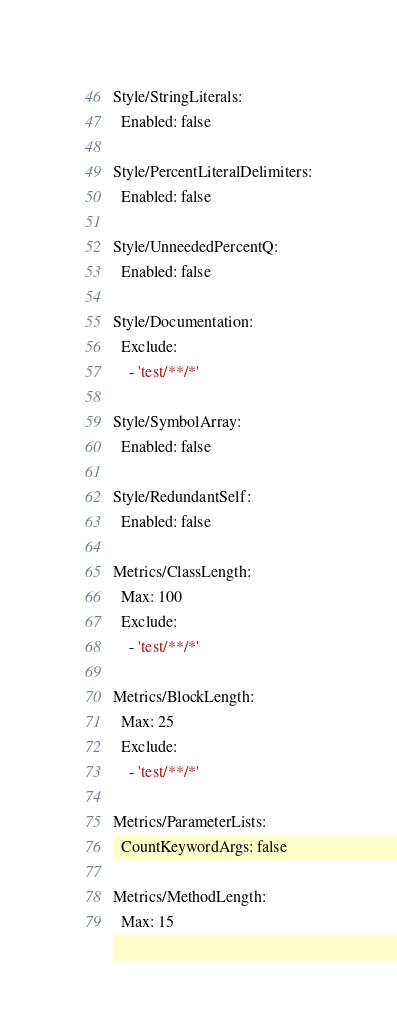<code> <loc_0><loc_0><loc_500><loc_500><_YAML_>Style/StringLiterals:
  Enabled: false

Style/PercentLiteralDelimiters:
  Enabled: false

Style/UnneededPercentQ:
  Enabled: false

Style/Documentation:
  Exclude:
    - 'test/**/*'

Style/SymbolArray:
  Enabled: false

Style/RedundantSelf:
  Enabled: false

Metrics/ClassLength:
  Max: 100
  Exclude:
    - 'test/**/*'

Metrics/BlockLength:
  Max: 25
  Exclude:
    - 'test/**/*'

Metrics/ParameterLists:
  CountKeywordArgs: false

Metrics/MethodLength:
  Max: 15
</code> 